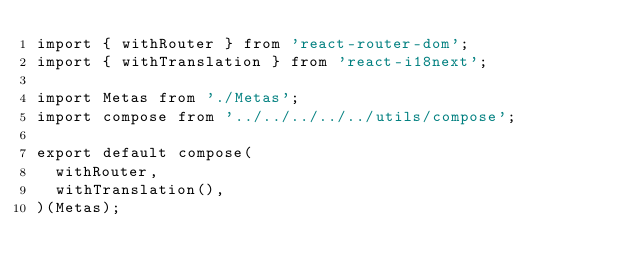<code> <loc_0><loc_0><loc_500><loc_500><_JavaScript_>import { withRouter } from 'react-router-dom';
import { withTranslation } from 'react-i18next';

import Metas from './Metas';
import compose from '../../../../../utils/compose';

export default compose(
  withRouter,
  withTranslation(),
)(Metas);
</code> 